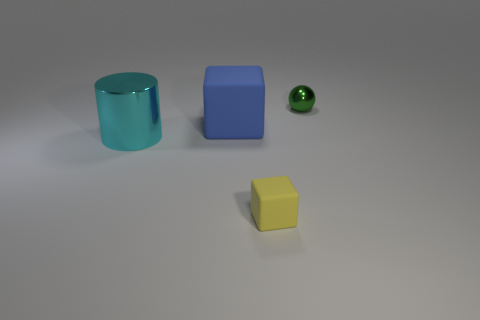Add 1 big spheres. How many objects exist? 5 Subtract all big purple spheres. Subtract all large rubber things. How many objects are left? 3 Add 4 yellow objects. How many yellow objects are left? 5 Add 4 green metal things. How many green metal things exist? 5 Subtract 0 green blocks. How many objects are left? 4 